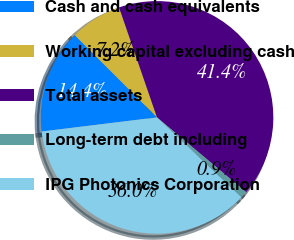<chart> <loc_0><loc_0><loc_500><loc_500><pie_chart><fcel>Cash and cash equivalents<fcel>Working capital excluding cash<fcel>Total assets<fcel>Long-term debt including<fcel>IPG Photonics Corporation<nl><fcel>14.43%<fcel>7.22%<fcel>41.39%<fcel>0.94%<fcel>36.02%<nl></chart> 